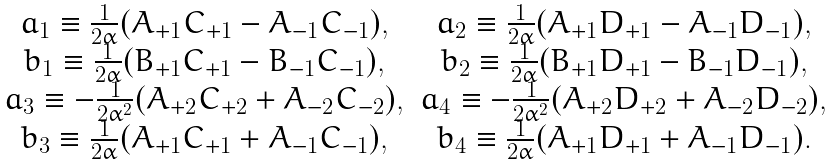Convert formula to latex. <formula><loc_0><loc_0><loc_500><loc_500>\begin{array} { c c } a _ { 1 } \equiv \frac { 1 } { 2 \alpha } ( A _ { + 1 } C _ { + 1 } - A _ { - 1 } C _ { - 1 } ) , & a _ { 2 } \equiv \frac { 1 } { 2 \alpha } ( A _ { + 1 } D _ { + 1 } - A _ { - 1 } D _ { - 1 } ) , \\ b _ { 1 } \equiv \frac { 1 } { 2 \alpha } ( B _ { + 1 } C _ { + 1 } - B _ { - 1 } C _ { - 1 } ) , & b _ { 2 } \equiv \frac { 1 } { 2 \alpha } ( B _ { + 1 } D _ { + 1 } - B _ { - 1 } D _ { - 1 } ) , \\ a _ { 3 } \equiv - \frac { 1 } { 2 \alpha ^ { 2 } } ( A _ { + 2 } C _ { + 2 } + A _ { - 2 } C _ { - 2 } ) , & a _ { 4 } \equiv - \frac { 1 } { 2 \alpha ^ { 2 } } ( A _ { + 2 } D _ { + 2 } + A _ { - 2 } D _ { - 2 } ) , \\ b _ { 3 } \equiv \frac { 1 } { 2 \alpha } ( A _ { + 1 } C _ { + 1 } + A _ { - 1 } C _ { - 1 } ) , & b _ { 4 } \equiv \frac { 1 } { 2 \alpha } ( A _ { + 1 } D _ { + 1 } + A _ { - 1 } D _ { - 1 } ) . \end{array}</formula> 